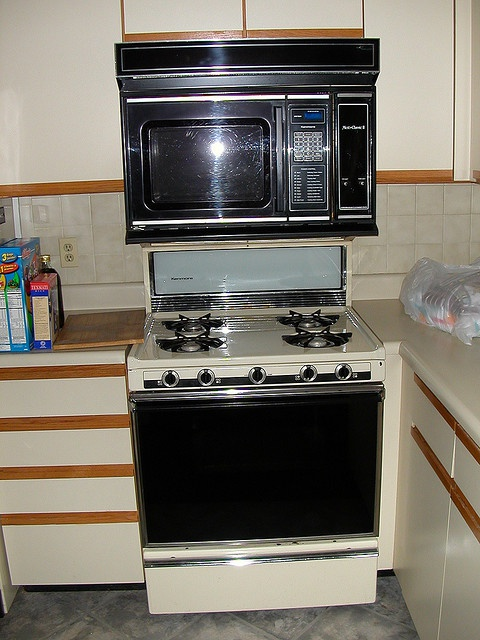Describe the objects in this image and their specific colors. I can see oven in darkgray, black, lightgray, and gray tones, microwave in darkgray, black, gray, and white tones, and bottle in darkgray, black, gray, and olive tones in this image. 